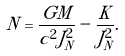Convert formula to latex. <formula><loc_0><loc_0><loc_500><loc_500>N = \frac { G M } { c ^ { 2 } J _ { N } ^ { 2 } } - \frac { K } { J _ { N } ^ { 2 } } .</formula> 